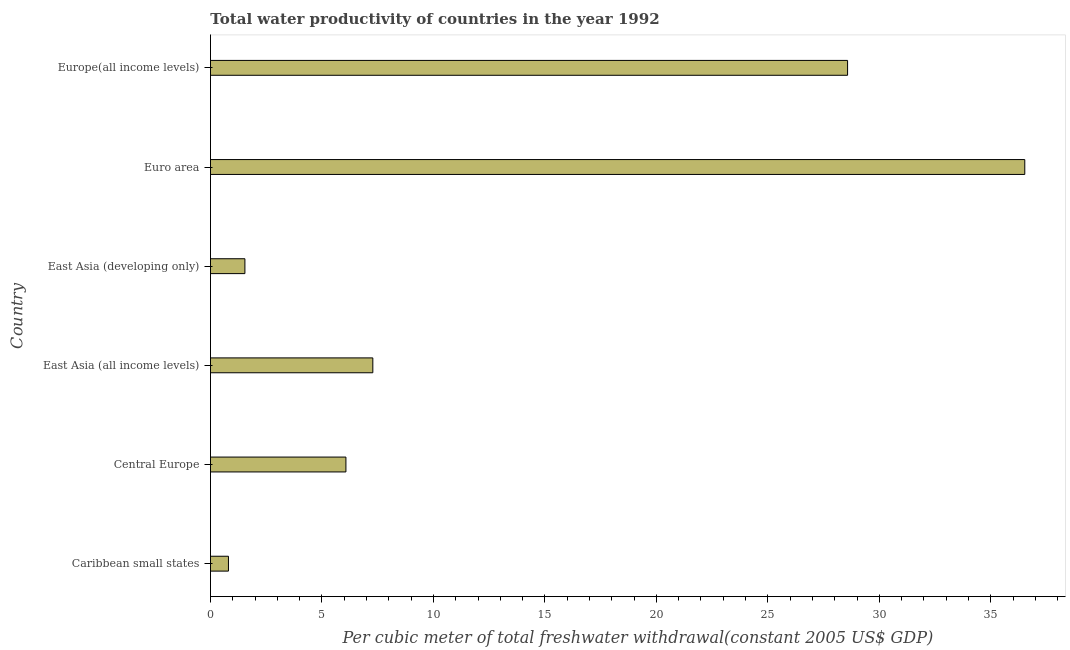What is the title of the graph?
Your response must be concise. Total water productivity of countries in the year 1992. What is the label or title of the X-axis?
Give a very brief answer. Per cubic meter of total freshwater withdrawal(constant 2005 US$ GDP). What is the label or title of the Y-axis?
Provide a short and direct response. Country. What is the total water productivity in Euro area?
Make the answer very short. 36.52. Across all countries, what is the maximum total water productivity?
Ensure brevity in your answer.  36.52. Across all countries, what is the minimum total water productivity?
Provide a short and direct response. 0.81. In which country was the total water productivity minimum?
Offer a very short reply. Caribbean small states. What is the sum of the total water productivity?
Keep it short and to the point. 80.81. What is the difference between the total water productivity in East Asia (developing only) and Europe(all income levels)?
Your answer should be very brief. -27.03. What is the average total water productivity per country?
Offer a terse response. 13.47. What is the median total water productivity?
Provide a short and direct response. 6.68. What is the ratio of the total water productivity in Central Europe to that in East Asia (all income levels)?
Offer a very short reply. 0.83. Is the difference between the total water productivity in Caribbean small states and Central Europe greater than the difference between any two countries?
Provide a short and direct response. No. What is the difference between the highest and the second highest total water productivity?
Offer a terse response. 7.95. Is the sum of the total water productivity in East Asia (all income levels) and Europe(all income levels) greater than the maximum total water productivity across all countries?
Give a very brief answer. No. What is the difference between the highest and the lowest total water productivity?
Keep it short and to the point. 35.72. In how many countries, is the total water productivity greater than the average total water productivity taken over all countries?
Offer a very short reply. 2. Are all the bars in the graph horizontal?
Your answer should be compact. Yes. What is the Per cubic meter of total freshwater withdrawal(constant 2005 US$ GDP) in Caribbean small states?
Ensure brevity in your answer.  0.81. What is the Per cubic meter of total freshwater withdrawal(constant 2005 US$ GDP) in Central Europe?
Provide a succinct answer. 6.07. What is the Per cubic meter of total freshwater withdrawal(constant 2005 US$ GDP) of East Asia (all income levels)?
Offer a very short reply. 7.28. What is the Per cubic meter of total freshwater withdrawal(constant 2005 US$ GDP) of East Asia (developing only)?
Your response must be concise. 1.54. What is the Per cubic meter of total freshwater withdrawal(constant 2005 US$ GDP) in Euro area?
Ensure brevity in your answer.  36.52. What is the Per cubic meter of total freshwater withdrawal(constant 2005 US$ GDP) of Europe(all income levels)?
Offer a very short reply. 28.58. What is the difference between the Per cubic meter of total freshwater withdrawal(constant 2005 US$ GDP) in Caribbean small states and Central Europe?
Offer a very short reply. -5.27. What is the difference between the Per cubic meter of total freshwater withdrawal(constant 2005 US$ GDP) in Caribbean small states and East Asia (all income levels)?
Provide a succinct answer. -6.48. What is the difference between the Per cubic meter of total freshwater withdrawal(constant 2005 US$ GDP) in Caribbean small states and East Asia (developing only)?
Provide a short and direct response. -0.74. What is the difference between the Per cubic meter of total freshwater withdrawal(constant 2005 US$ GDP) in Caribbean small states and Euro area?
Offer a very short reply. -35.72. What is the difference between the Per cubic meter of total freshwater withdrawal(constant 2005 US$ GDP) in Caribbean small states and Europe(all income levels)?
Offer a very short reply. -27.77. What is the difference between the Per cubic meter of total freshwater withdrawal(constant 2005 US$ GDP) in Central Europe and East Asia (all income levels)?
Your response must be concise. -1.21. What is the difference between the Per cubic meter of total freshwater withdrawal(constant 2005 US$ GDP) in Central Europe and East Asia (developing only)?
Offer a very short reply. 4.53. What is the difference between the Per cubic meter of total freshwater withdrawal(constant 2005 US$ GDP) in Central Europe and Euro area?
Make the answer very short. -30.45. What is the difference between the Per cubic meter of total freshwater withdrawal(constant 2005 US$ GDP) in Central Europe and Europe(all income levels)?
Offer a very short reply. -22.5. What is the difference between the Per cubic meter of total freshwater withdrawal(constant 2005 US$ GDP) in East Asia (all income levels) and East Asia (developing only)?
Your response must be concise. 5.74. What is the difference between the Per cubic meter of total freshwater withdrawal(constant 2005 US$ GDP) in East Asia (all income levels) and Euro area?
Your answer should be compact. -29.24. What is the difference between the Per cubic meter of total freshwater withdrawal(constant 2005 US$ GDP) in East Asia (all income levels) and Europe(all income levels)?
Offer a terse response. -21.29. What is the difference between the Per cubic meter of total freshwater withdrawal(constant 2005 US$ GDP) in East Asia (developing only) and Euro area?
Your answer should be compact. -34.98. What is the difference between the Per cubic meter of total freshwater withdrawal(constant 2005 US$ GDP) in East Asia (developing only) and Europe(all income levels)?
Give a very brief answer. -27.03. What is the difference between the Per cubic meter of total freshwater withdrawal(constant 2005 US$ GDP) in Euro area and Europe(all income levels)?
Make the answer very short. 7.95. What is the ratio of the Per cubic meter of total freshwater withdrawal(constant 2005 US$ GDP) in Caribbean small states to that in Central Europe?
Make the answer very short. 0.13. What is the ratio of the Per cubic meter of total freshwater withdrawal(constant 2005 US$ GDP) in Caribbean small states to that in East Asia (all income levels)?
Your answer should be compact. 0.11. What is the ratio of the Per cubic meter of total freshwater withdrawal(constant 2005 US$ GDP) in Caribbean small states to that in East Asia (developing only)?
Offer a terse response. 0.52. What is the ratio of the Per cubic meter of total freshwater withdrawal(constant 2005 US$ GDP) in Caribbean small states to that in Euro area?
Your response must be concise. 0.02. What is the ratio of the Per cubic meter of total freshwater withdrawal(constant 2005 US$ GDP) in Caribbean small states to that in Europe(all income levels)?
Make the answer very short. 0.03. What is the ratio of the Per cubic meter of total freshwater withdrawal(constant 2005 US$ GDP) in Central Europe to that in East Asia (all income levels)?
Give a very brief answer. 0.83. What is the ratio of the Per cubic meter of total freshwater withdrawal(constant 2005 US$ GDP) in Central Europe to that in East Asia (developing only)?
Make the answer very short. 3.93. What is the ratio of the Per cubic meter of total freshwater withdrawal(constant 2005 US$ GDP) in Central Europe to that in Euro area?
Keep it short and to the point. 0.17. What is the ratio of the Per cubic meter of total freshwater withdrawal(constant 2005 US$ GDP) in Central Europe to that in Europe(all income levels)?
Provide a succinct answer. 0.21. What is the ratio of the Per cubic meter of total freshwater withdrawal(constant 2005 US$ GDP) in East Asia (all income levels) to that in East Asia (developing only)?
Offer a very short reply. 4.71. What is the ratio of the Per cubic meter of total freshwater withdrawal(constant 2005 US$ GDP) in East Asia (all income levels) to that in Euro area?
Keep it short and to the point. 0.2. What is the ratio of the Per cubic meter of total freshwater withdrawal(constant 2005 US$ GDP) in East Asia (all income levels) to that in Europe(all income levels)?
Your answer should be very brief. 0.26. What is the ratio of the Per cubic meter of total freshwater withdrawal(constant 2005 US$ GDP) in East Asia (developing only) to that in Euro area?
Your answer should be compact. 0.04. What is the ratio of the Per cubic meter of total freshwater withdrawal(constant 2005 US$ GDP) in East Asia (developing only) to that in Europe(all income levels)?
Your answer should be compact. 0.05. What is the ratio of the Per cubic meter of total freshwater withdrawal(constant 2005 US$ GDP) in Euro area to that in Europe(all income levels)?
Provide a short and direct response. 1.28. 